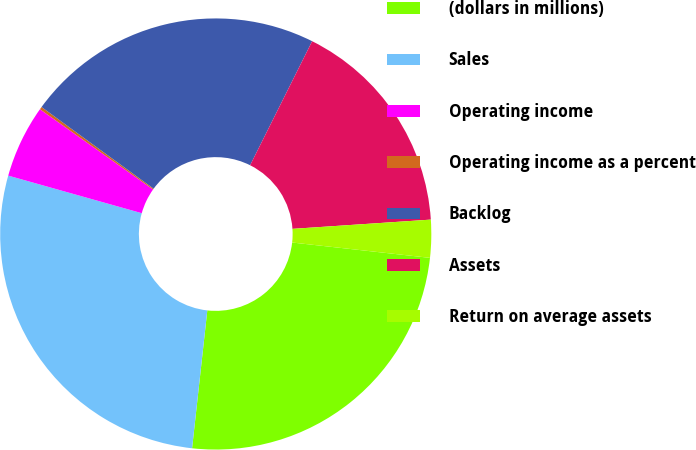<chart> <loc_0><loc_0><loc_500><loc_500><pie_chart><fcel>(dollars in millions)<fcel>Sales<fcel>Operating income<fcel>Operating income as a percent<fcel>Backlog<fcel>Assets<fcel>Return on average assets<nl><fcel>24.99%<fcel>27.62%<fcel>5.46%<fcel>0.2%<fcel>22.36%<fcel>16.56%<fcel>2.83%<nl></chart> 